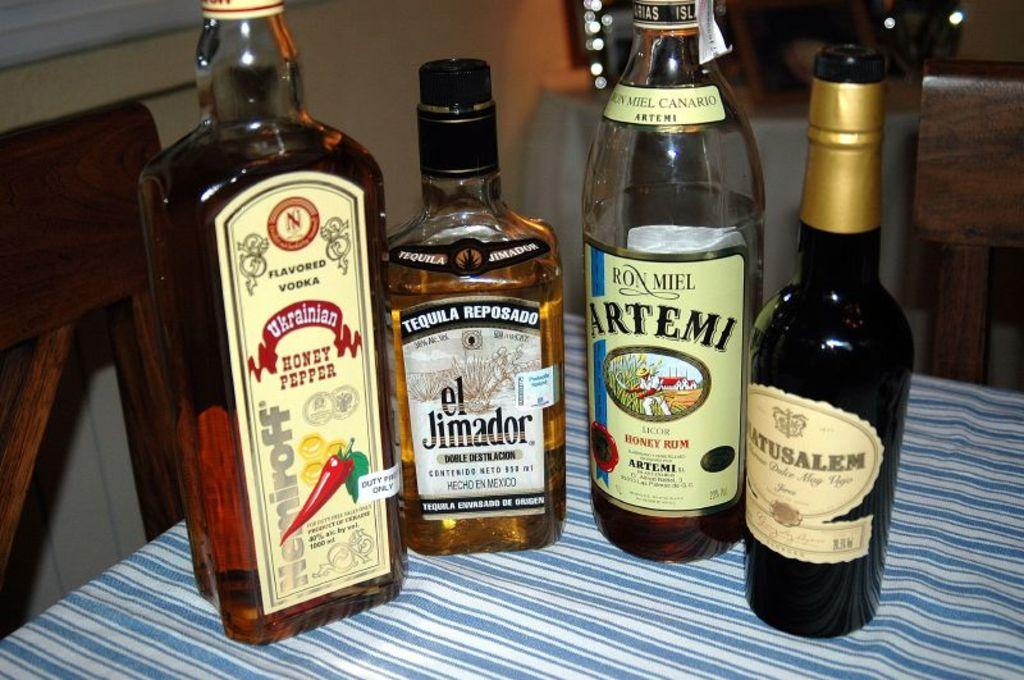<image>
Offer a succinct explanation of the picture presented. Four liquor bottles on a tablecloth, including Ukranian Honey Pepper flavored vodka, el Jimador Tequila Reposado, Ron Miel Artemi Honey Rum 